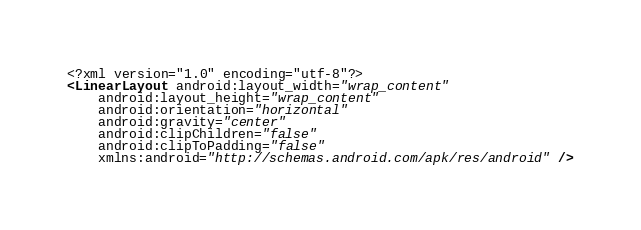Convert code to text. <code><loc_0><loc_0><loc_500><loc_500><_XML_><?xml version="1.0" encoding="utf-8"?>
<LinearLayout android:layout_width="wrap_content"
    android:layout_height="wrap_content"
    android:orientation="horizontal"
    android:gravity="center"
    android:clipChildren="false"
    android:clipToPadding="false"
    xmlns:android="http://schemas.android.com/apk/res/android" /></code> 